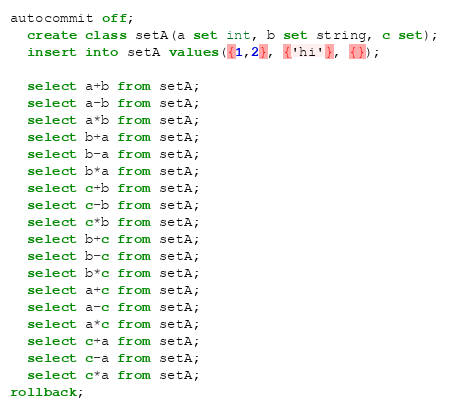Convert code to text. <code><loc_0><loc_0><loc_500><loc_500><_SQL_>autocommit off;
  create class setA(a set int, b set string, c set);
  insert into setA values({1,2}, {'hi'}, {});
  
  select a+b from setA;
  select a-b from setA;
  select a*b from setA;
  select b+a from setA;
  select b-a from setA;
  select b*a from setA;
  select c+b from setA;
  select c-b from setA;
  select c*b from setA;
  select b+c from setA;
  select b-c from setA;
  select b*c from setA;
  select a+c from setA;
  select a-c from setA;
  select a*c from setA;
  select c+a from setA;
  select c-a from setA;
  select c*a from setA;
rollback;
</code> 